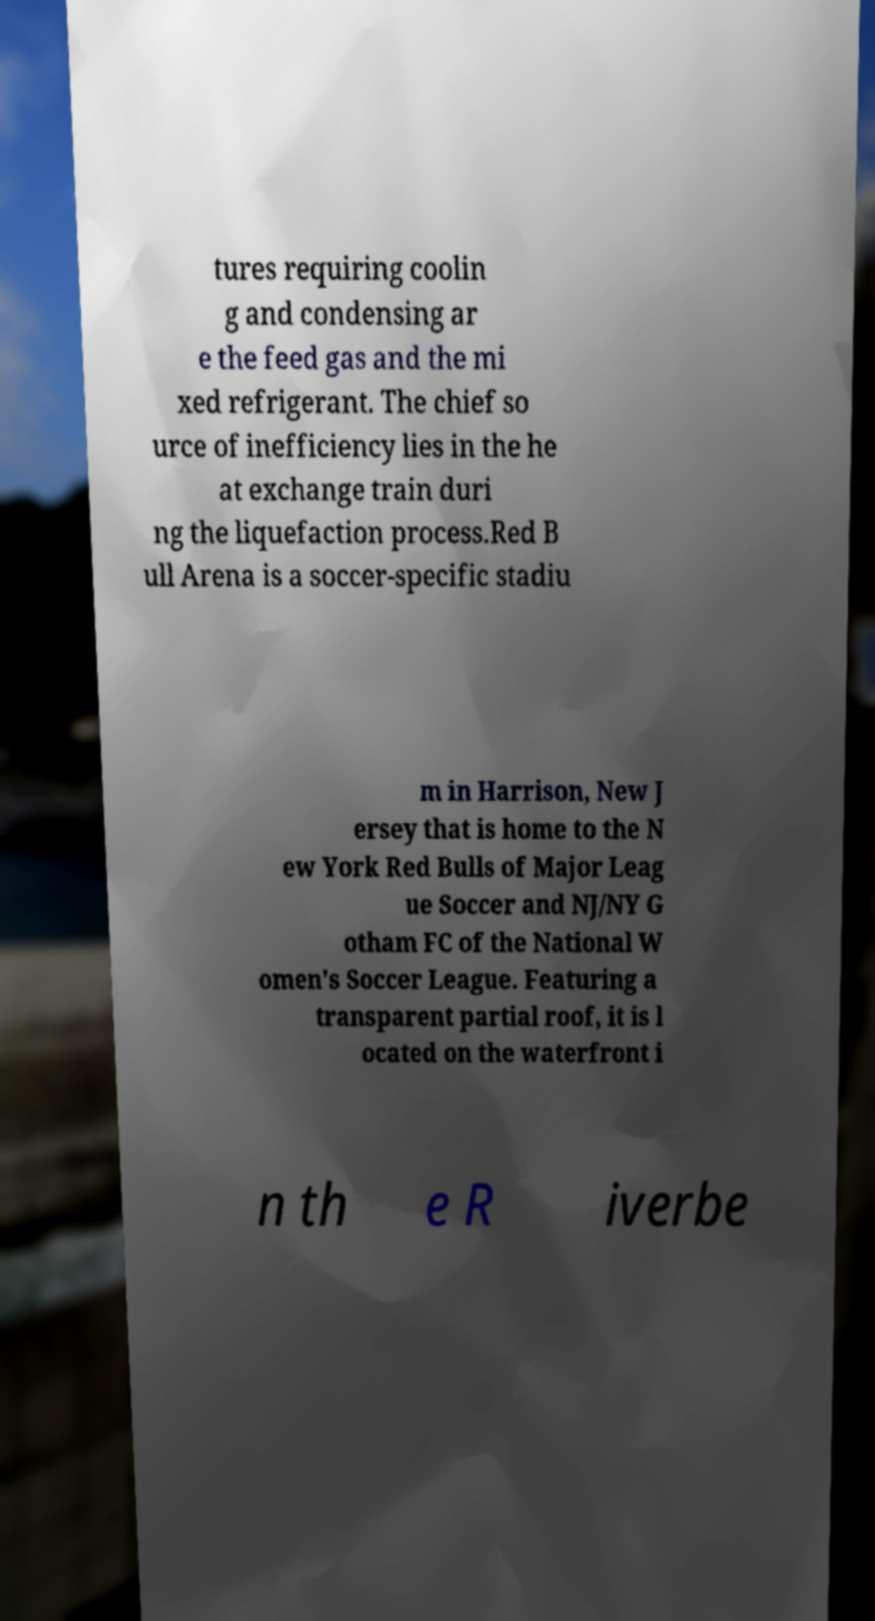Can you read and provide the text displayed in the image?This photo seems to have some interesting text. Can you extract and type it out for me? tures requiring coolin g and condensing ar e the feed gas and the mi xed refrigerant. The chief so urce of inefficiency lies in the he at exchange train duri ng the liquefaction process.Red B ull Arena is a soccer-specific stadiu m in Harrison, New J ersey that is home to the N ew York Red Bulls of Major Leag ue Soccer and NJ/NY G otham FC of the National W omen's Soccer League. Featuring a transparent partial roof, it is l ocated on the waterfront i n th e R iverbe 